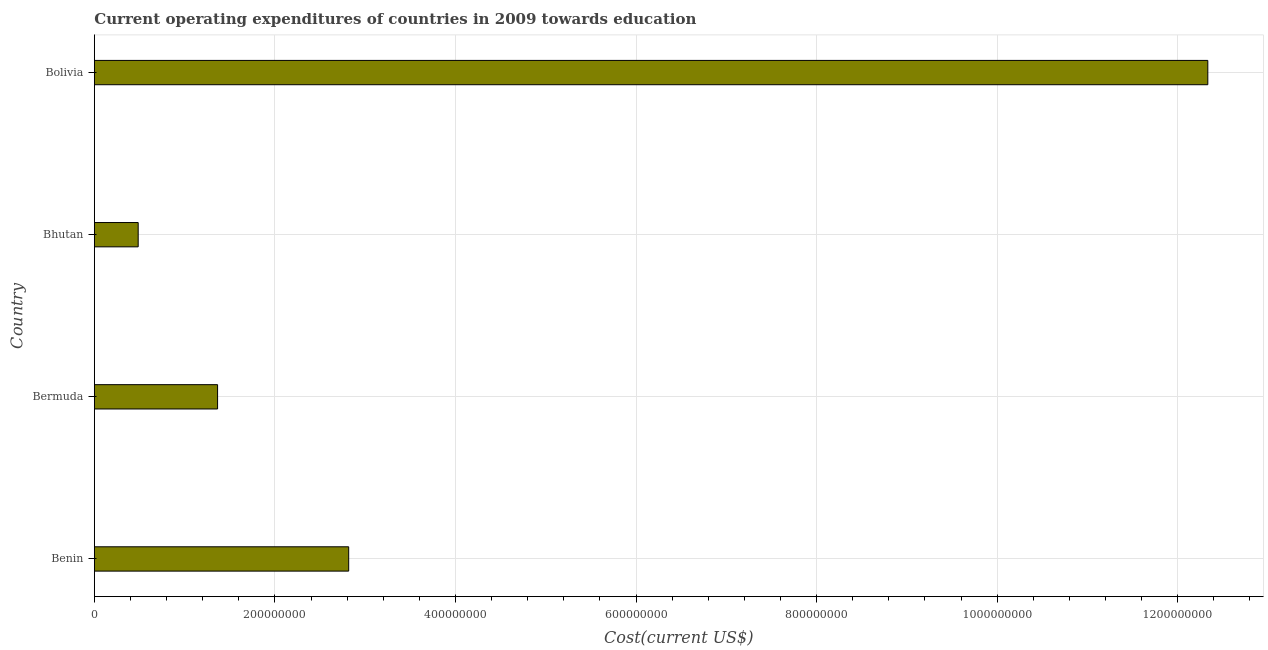Does the graph contain any zero values?
Give a very brief answer. No. Does the graph contain grids?
Your answer should be compact. Yes. What is the title of the graph?
Your answer should be very brief. Current operating expenditures of countries in 2009 towards education. What is the label or title of the X-axis?
Offer a terse response. Cost(current US$). What is the label or title of the Y-axis?
Keep it short and to the point. Country. What is the education expenditure in Bolivia?
Your answer should be compact. 1.23e+09. Across all countries, what is the maximum education expenditure?
Offer a very short reply. 1.23e+09. Across all countries, what is the minimum education expenditure?
Make the answer very short. 4.86e+07. In which country was the education expenditure maximum?
Your answer should be very brief. Bolivia. In which country was the education expenditure minimum?
Your answer should be compact. Bhutan. What is the sum of the education expenditure?
Provide a short and direct response. 1.70e+09. What is the difference between the education expenditure in Bermuda and Bolivia?
Provide a succinct answer. -1.10e+09. What is the average education expenditure per country?
Offer a very short reply. 4.25e+08. What is the median education expenditure?
Offer a very short reply. 2.09e+08. In how many countries, is the education expenditure greater than 1200000000 US$?
Offer a terse response. 1. What is the ratio of the education expenditure in Benin to that in Bolivia?
Your answer should be compact. 0.23. Is the difference between the education expenditure in Benin and Bolivia greater than the difference between any two countries?
Offer a very short reply. No. What is the difference between the highest and the second highest education expenditure?
Provide a succinct answer. 9.52e+08. Is the sum of the education expenditure in Bhutan and Bolivia greater than the maximum education expenditure across all countries?
Provide a succinct answer. Yes. What is the difference between the highest and the lowest education expenditure?
Your response must be concise. 1.18e+09. In how many countries, is the education expenditure greater than the average education expenditure taken over all countries?
Keep it short and to the point. 1. How many bars are there?
Your response must be concise. 4. How many countries are there in the graph?
Offer a terse response. 4. What is the Cost(current US$) of Benin?
Your response must be concise. 2.82e+08. What is the Cost(current US$) in Bermuda?
Your response must be concise. 1.36e+08. What is the Cost(current US$) of Bhutan?
Make the answer very short. 4.86e+07. What is the Cost(current US$) of Bolivia?
Your answer should be very brief. 1.23e+09. What is the difference between the Cost(current US$) in Benin and Bermuda?
Offer a terse response. 1.45e+08. What is the difference between the Cost(current US$) in Benin and Bhutan?
Your response must be concise. 2.33e+08. What is the difference between the Cost(current US$) in Benin and Bolivia?
Provide a short and direct response. -9.52e+08. What is the difference between the Cost(current US$) in Bermuda and Bhutan?
Your answer should be compact. 8.79e+07. What is the difference between the Cost(current US$) in Bermuda and Bolivia?
Ensure brevity in your answer.  -1.10e+09. What is the difference between the Cost(current US$) in Bhutan and Bolivia?
Offer a terse response. -1.18e+09. What is the ratio of the Cost(current US$) in Benin to that in Bermuda?
Provide a succinct answer. 2.06. What is the ratio of the Cost(current US$) in Benin to that in Bolivia?
Ensure brevity in your answer.  0.23. What is the ratio of the Cost(current US$) in Bermuda to that in Bhutan?
Ensure brevity in your answer.  2.81. What is the ratio of the Cost(current US$) in Bermuda to that in Bolivia?
Ensure brevity in your answer.  0.11. What is the ratio of the Cost(current US$) in Bhutan to that in Bolivia?
Make the answer very short. 0.04. 